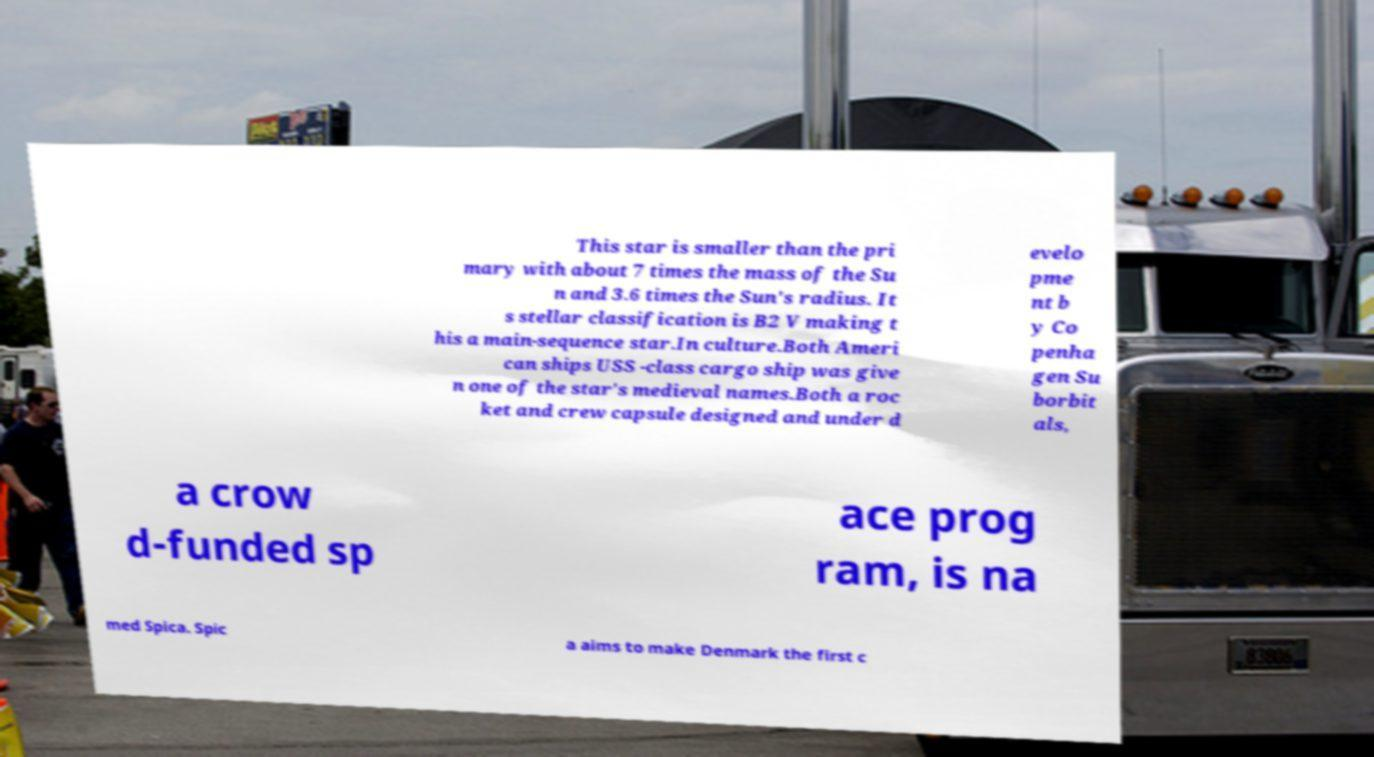Could you extract and type out the text from this image? This star is smaller than the pri mary with about 7 times the mass of the Su n and 3.6 times the Sun's radius. It s stellar classification is B2 V making t his a main-sequence star.In culture.Both Ameri can ships USS -class cargo ship was give n one of the star's medieval names.Both a roc ket and crew capsule designed and under d evelo pme nt b y Co penha gen Su borbit als, a crow d-funded sp ace prog ram, is na med Spica. Spic a aims to make Denmark the first c 